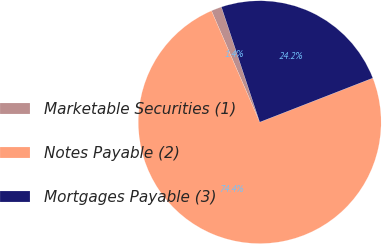Convert chart to OTSL. <chart><loc_0><loc_0><loc_500><loc_500><pie_chart><fcel>Marketable Securities (1)<fcel>Notes Payable (2)<fcel>Mortgages Payable (3)<nl><fcel>1.4%<fcel>74.41%<fcel>24.19%<nl></chart> 